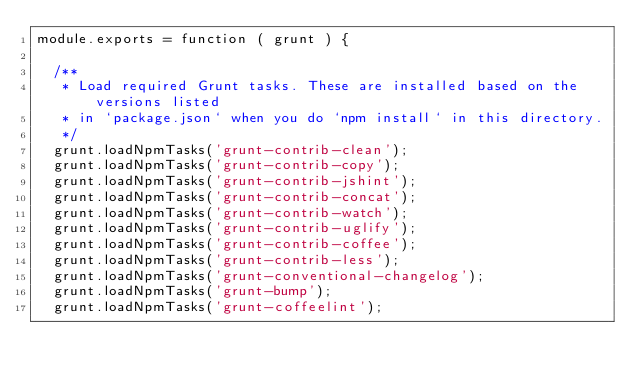<code> <loc_0><loc_0><loc_500><loc_500><_JavaScript_>module.exports = function ( grunt ) {
  
  /** 
   * Load required Grunt tasks. These are installed based on the versions listed
   * in `package.json` when you do `npm install` in this directory.
   */
  grunt.loadNpmTasks('grunt-contrib-clean');
  grunt.loadNpmTasks('grunt-contrib-copy');
  grunt.loadNpmTasks('grunt-contrib-jshint');
  grunt.loadNpmTasks('grunt-contrib-concat');
  grunt.loadNpmTasks('grunt-contrib-watch');
  grunt.loadNpmTasks('grunt-contrib-uglify');
  grunt.loadNpmTasks('grunt-contrib-coffee');
  grunt.loadNpmTasks('grunt-contrib-less');
  grunt.loadNpmTasks('grunt-conventional-changelog');
  grunt.loadNpmTasks('grunt-bump');
  grunt.loadNpmTasks('grunt-coffeelint');</code> 